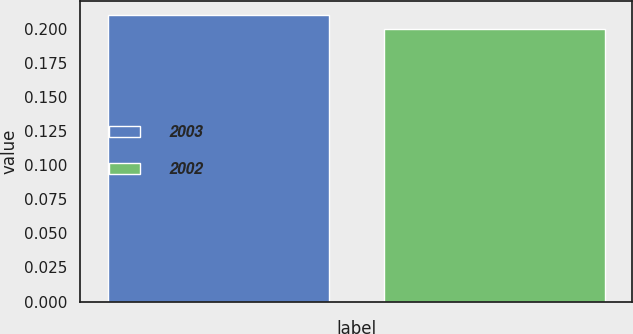Convert chart to OTSL. <chart><loc_0><loc_0><loc_500><loc_500><bar_chart><fcel>2003<fcel>2002<nl><fcel>0.21<fcel>0.2<nl></chart> 